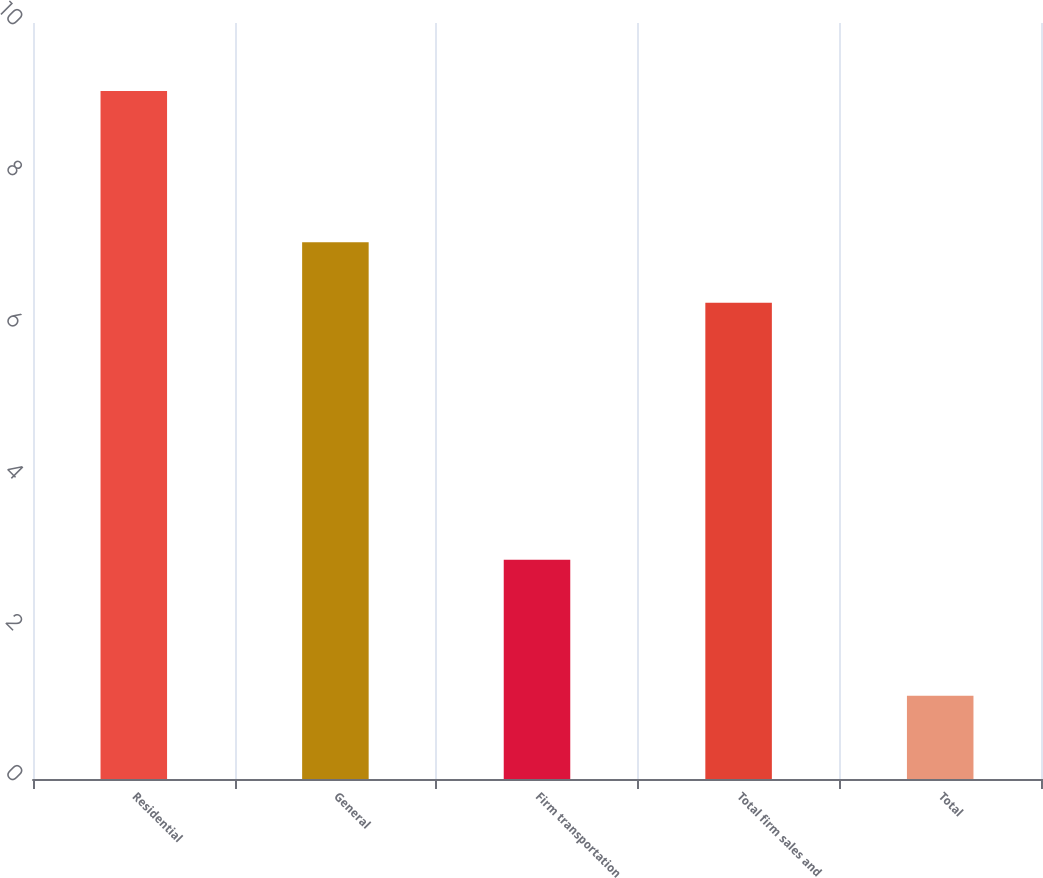Convert chart. <chart><loc_0><loc_0><loc_500><loc_500><bar_chart><fcel>Residential<fcel>General<fcel>Firm transportation<fcel>Total firm sales and<fcel>Total<nl><fcel>9.1<fcel>7.1<fcel>2.9<fcel>6.3<fcel>1.1<nl></chart> 